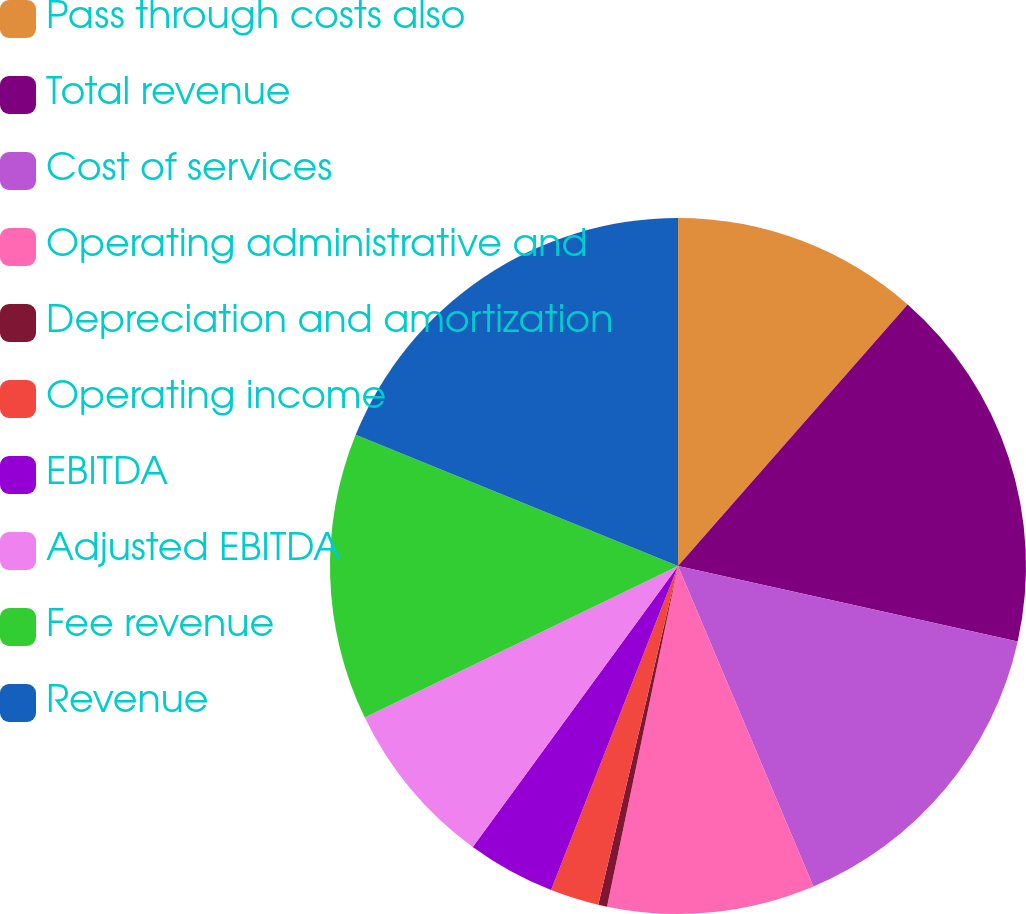Convert chart. <chart><loc_0><loc_0><loc_500><loc_500><pie_chart><fcel>Pass through costs also<fcel>Total revenue<fcel>Cost of services<fcel>Operating administrative and<fcel>Depreciation and amortization<fcel>Operating income<fcel>EBITDA<fcel>Adjusted EBITDA<fcel>Fee revenue<fcel>Revenue<nl><fcel>11.47%<fcel>17.01%<fcel>15.16%<fcel>9.63%<fcel>0.41%<fcel>2.26%<fcel>4.1%<fcel>7.79%<fcel>13.32%<fcel>18.85%<nl></chart> 